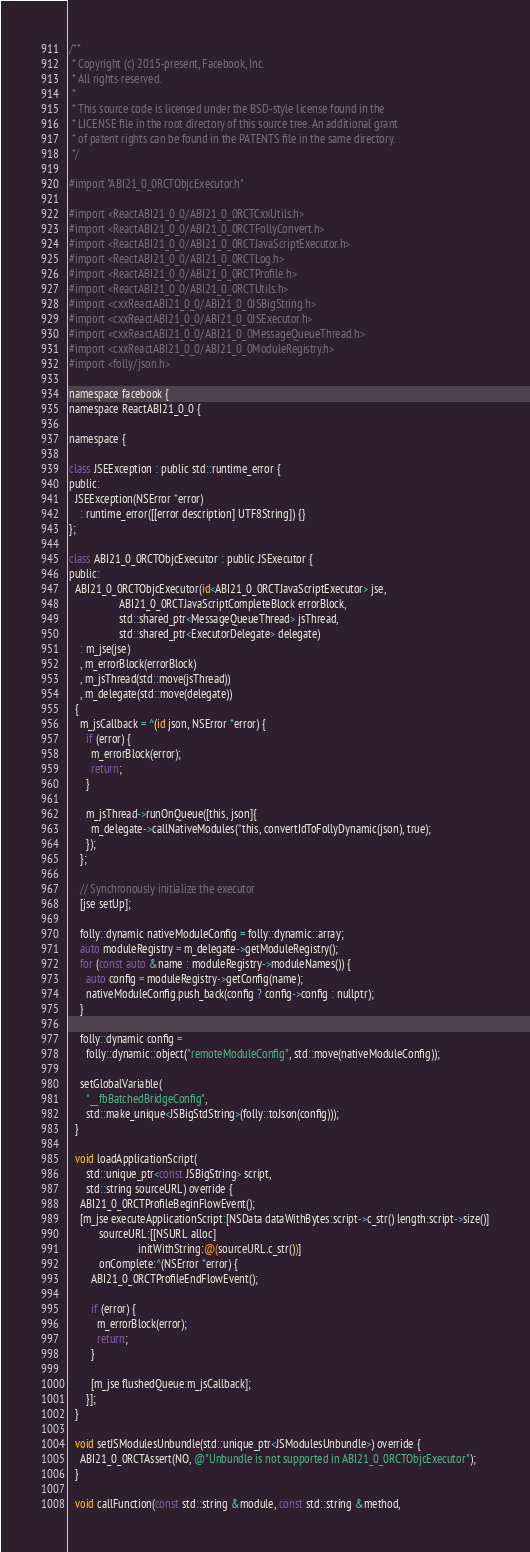<code> <loc_0><loc_0><loc_500><loc_500><_ObjectiveC_>/**
 * Copyright (c) 2015-present, Facebook, Inc.
 * All rights reserved.
 *
 * This source code is licensed under the BSD-style license found in the
 * LICENSE file in the root directory of this source tree. An additional grant
 * of patent rights can be found in the PATENTS file in the same directory.
 */

#import "ABI21_0_0RCTObjcExecutor.h"

#import <ReactABI21_0_0/ABI21_0_0RCTCxxUtils.h>
#import <ReactABI21_0_0/ABI21_0_0RCTFollyConvert.h>
#import <ReactABI21_0_0/ABI21_0_0RCTJavaScriptExecutor.h>
#import <ReactABI21_0_0/ABI21_0_0RCTLog.h>
#import <ReactABI21_0_0/ABI21_0_0RCTProfile.h>
#import <ReactABI21_0_0/ABI21_0_0RCTUtils.h>
#import <cxxReactABI21_0_0/ABI21_0_0JSBigString.h>
#import <cxxReactABI21_0_0/ABI21_0_0JSExecutor.h>
#import <cxxReactABI21_0_0/ABI21_0_0MessageQueueThread.h>
#import <cxxReactABI21_0_0/ABI21_0_0ModuleRegistry.h>
#import <folly/json.h>

namespace facebook {
namespace ReactABI21_0_0 {

namespace {

class JSEException : public std::runtime_error {
public:
  JSEException(NSError *error)
    : runtime_error([[error description] UTF8String]) {}
};

class ABI21_0_0RCTObjcExecutor : public JSExecutor {
public:
  ABI21_0_0RCTObjcExecutor(id<ABI21_0_0RCTJavaScriptExecutor> jse,
                  ABI21_0_0RCTJavaScriptCompleteBlock errorBlock,
                  std::shared_ptr<MessageQueueThread> jsThread,
                  std::shared_ptr<ExecutorDelegate> delegate)
    : m_jse(jse)
    , m_errorBlock(errorBlock)
    , m_jsThread(std::move(jsThread))
    , m_delegate(std::move(delegate))
  {
    m_jsCallback = ^(id json, NSError *error) {
      if (error) {
        m_errorBlock(error);
        return;
      }

      m_jsThread->runOnQueue([this, json]{
        m_delegate->callNativeModules(*this, convertIdToFollyDynamic(json), true);
      });
    };

    // Synchronously initialize the executor
    [jse setUp];

    folly::dynamic nativeModuleConfig = folly::dynamic::array;
    auto moduleRegistry = m_delegate->getModuleRegistry();
    for (const auto &name : moduleRegistry->moduleNames()) {
      auto config = moduleRegistry->getConfig(name);
      nativeModuleConfig.push_back(config ? config->config : nullptr);
    }

    folly::dynamic config =
      folly::dynamic::object("remoteModuleConfig", std::move(nativeModuleConfig));

    setGlobalVariable(
      "__fbBatchedBridgeConfig",
      std::make_unique<JSBigStdString>(folly::toJson(config)));
  }

  void loadApplicationScript(
      std::unique_ptr<const JSBigString> script,
      std::string sourceURL) override {
    ABI21_0_0RCTProfileBeginFlowEvent();
    [m_jse executeApplicationScript:[NSData dataWithBytes:script->c_str() length:script->size()]
           sourceURL:[[NSURL alloc]
                         initWithString:@(sourceURL.c_str())]
           onComplete:^(NSError *error) {
        ABI21_0_0RCTProfileEndFlowEvent();

        if (error) {
          m_errorBlock(error);
          return;
        }

        [m_jse flushedQueue:m_jsCallback];
      }];
  }

  void setJSModulesUnbundle(std::unique_ptr<JSModulesUnbundle>) override {
    ABI21_0_0RCTAssert(NO, @"Unbundle is not supported in ABI21_0_0RCTObjcExecutor");
  }

  void callFunction(const std::string &module, const std::string &method,</code> 